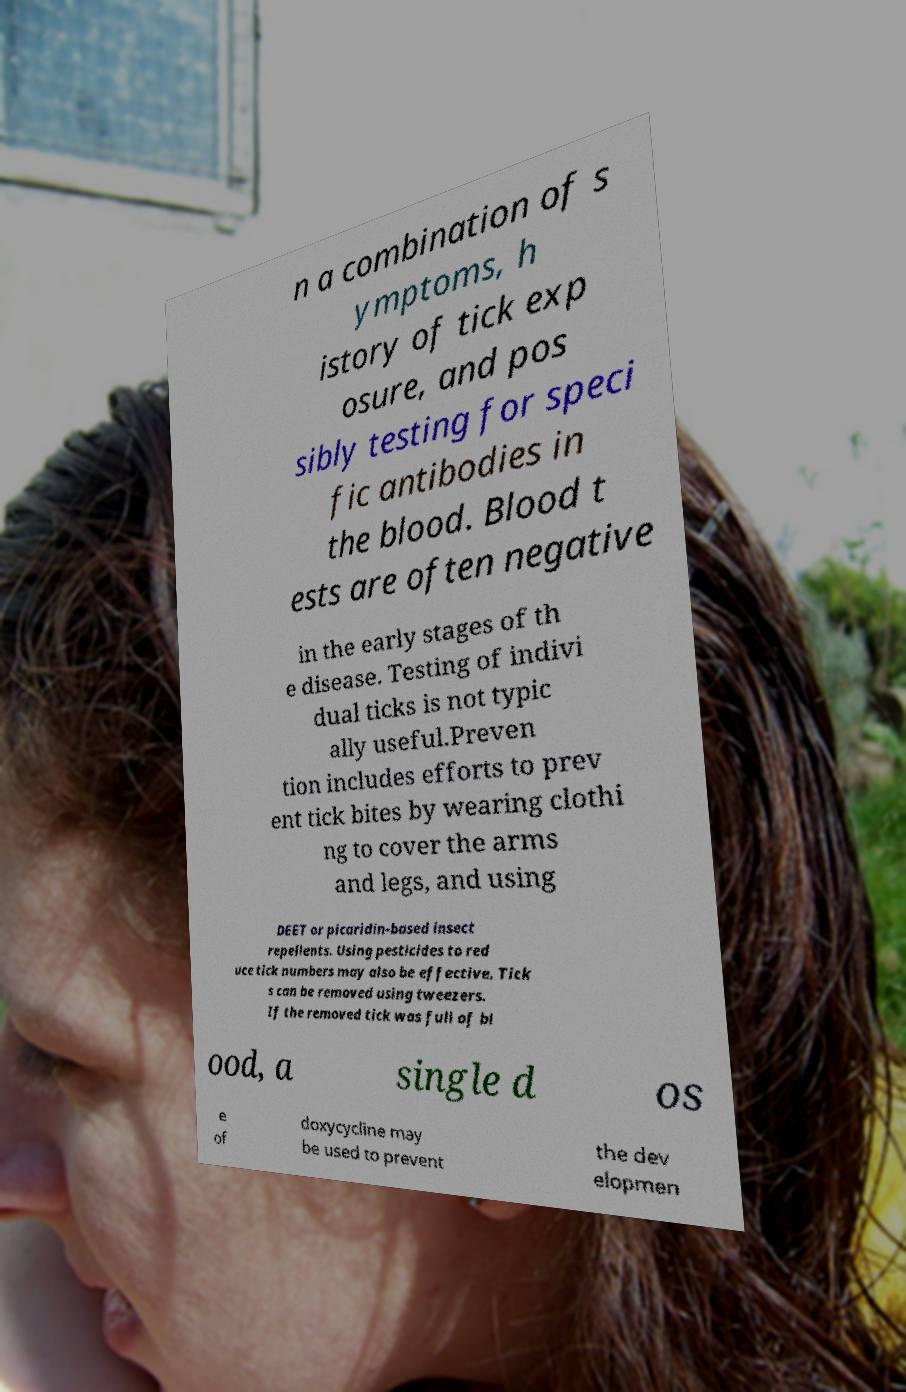Can you read and provide the text displayed in the image?This photo seems to have some interesting text. Can you extract and type it out for me? n a combination of s ymptoms, h istory of tick exp osure, and pos sibly testing for speci fic antibodies in the blood. Blood t ests are often negative in the early stages of th e disease. Testing of indivi dual ticks is not typic ally useful.Preven tion includes efforts to prev ent tick bites by wearing clothi ng to cover the arms and legs, and using DEET or picaridin-based insect repellents. Using pesticides to red uce tick numbers may also be effective. Tick s can be removed using tweezers. If the removed tick was full of bl ood, a single d os e of doxycycline may be used to prevent the dev elopmen 